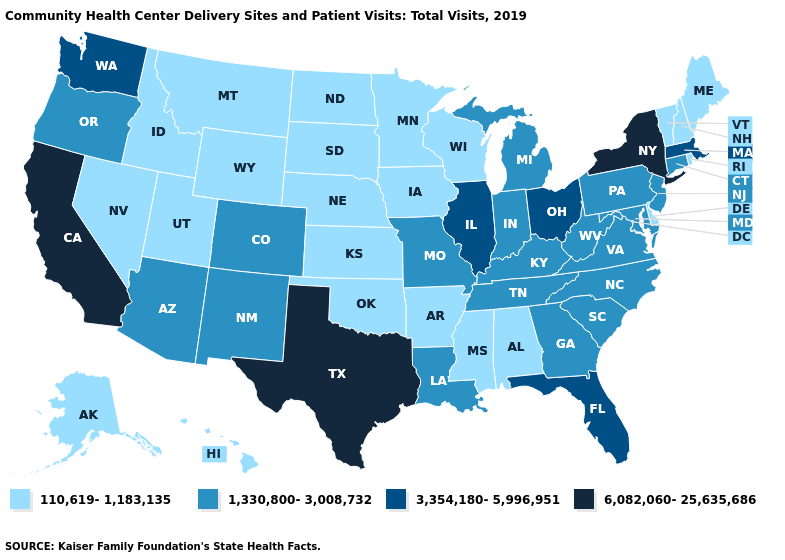Name the states that have a value in the range 3,354,180-5,996,951?
Concise answer only. Florida, Illinois, Massachusetts, Ohio, Washington. What is the lowest value in the West?
Answer briefly. 110,619-1,183,135. What is the value of Nebraska?
Give a very brief answer. 110,619-1,183,135. How many symbols are there in the legend?
Give a very brief answer. 4. Among the states that border Indiana , does Michigan have the lowest value?
Be succinct. Yes. Name the states that have a value in the range 3,354,180-5,996,951?
Write a very short answer. Florida, Illinois, Massachusetts, Ohio, Washington. Name the states that have a value in the range 3,354,180-5,996,951?
Keep it brief. Florida, Illinois, Massachusetts, Ohio, Washington. What is the value of Florida?
Keep it brief. 3,354,180-5,996,951. What is the value of Kentucky?
Concise answer only. 1,330,800-3,008,732. What is the value of Hawaii?
Short answer required. 110,619-1,183,135. Does California have the highest value in the USA?
Write a very short answer. Yes. Name the states that have a value in the range 1,330,800-3,008,732?
Quick response, please. Arizona, Colorado, Connecticut, Georgia, Indiana, Kentucky, Louisiana, Maryland, Michigan, Missouri, New Jersey, New Mexico, North Carolina, Oregon, Pennsylvania, South Carolina, Tennessee, Virginia, West Virginia. Among the states that border Missouri , does Tennessee have the highest value?
Keep it brief. No. What is the highest value in states that border Indiana?
Write a very short answer. 3,354,180-5,996,951. Does Arkansas have the lowest value in the South?
Be succinct. Yes. 